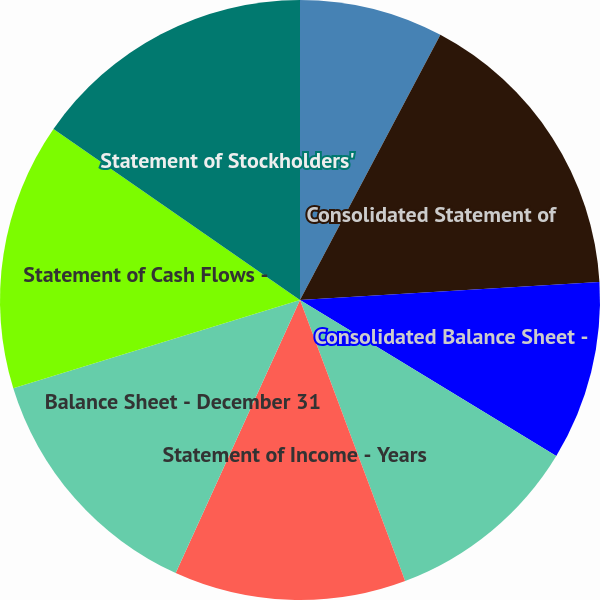Convert chart. <chart><loc_0><loc_0><loc_500><loc_500><pie_chart><fcel>Report of Independent<fcel>Consolidated Statement of<fcel>Consolidated Balance Sheet -<fcel>Consolidated Statement of Cash<fcel>Statement of Income - Years<fcel>Balance Sheet - December 31<fcel>Statement of Cash Flows -<fcel>Statement of Stockholders'<nl><fcel>7.75%<fcel>16.3%<fcel>9.65%<fcel>10.6%<fcel>12.5%<fcel>13.45%<fcel>14.4%<fcel>15.35%<nl></chart> 